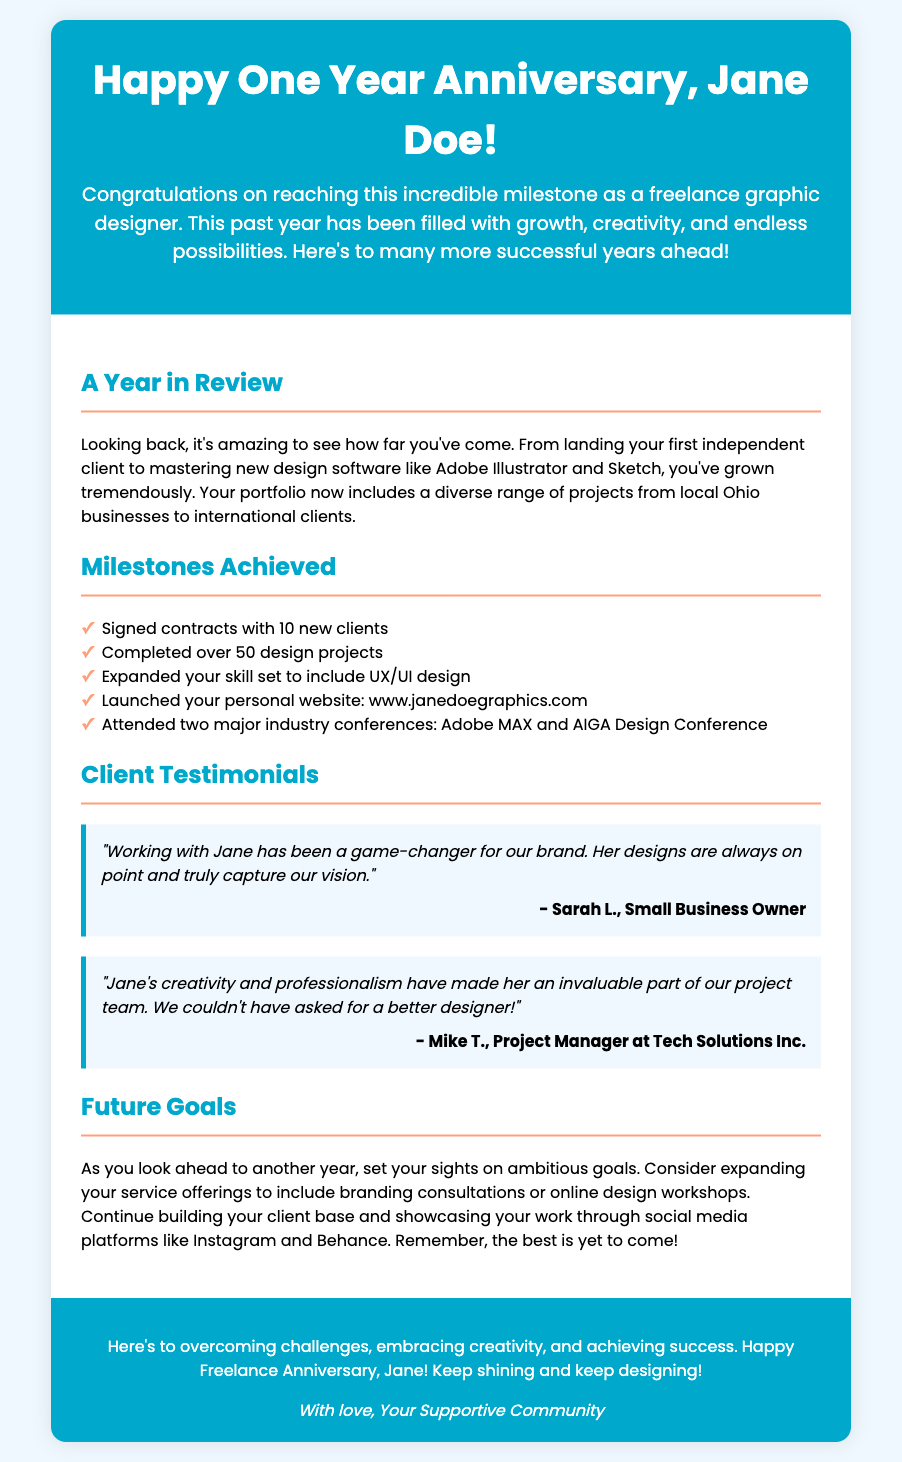What is the name of the person celebrating their freelance anniversary? The card addresses the individual as "Jane Doe," which is the name of the person whose anniversary is being celebrated.
Answer: Jane Doe How many design projects has Jane completed? The document states that Jane has completed "over 50 design projects."
Answer: over 50 What color is the background of the card? The background color of the card is described as "#f0f8ff," which is a soft light color.
Answer: #f0f8ff What website did Jane launch? The document mentions the website as “www.janedoegraphics.com,” which is her personal website.
Answer: www.janedoegraphics.com Name one industry conference Jane attended. The document lists two conferences attended, one of which is "Adobe MAX," making it a valid answer.
Answer: Adobe MAX How many new clients did Jane sign contracts with? The text specifies that Jane signed contracts with "10 new clients," which is a direct reference in the document.
Answer: 10 new clients What positive feedback did Sarah L. give about Jane? Sarah L. mentioned that "her designs are always on point and truly capture our vision," providing specific praise.
Answer: "her designs are always on point and truly capture our vision" What future goals does the document suggest for Jane? The card encourages Jane to consider "expanding your service offerings," indicating a direction for future growth.
Answer: expanding your service offerings What is the main theme of the card? The card celebrates the milestone of Jane's freelance anniversary, highlighting achievements and future aspirations.
Answer: celebrating the freelance anniversary 